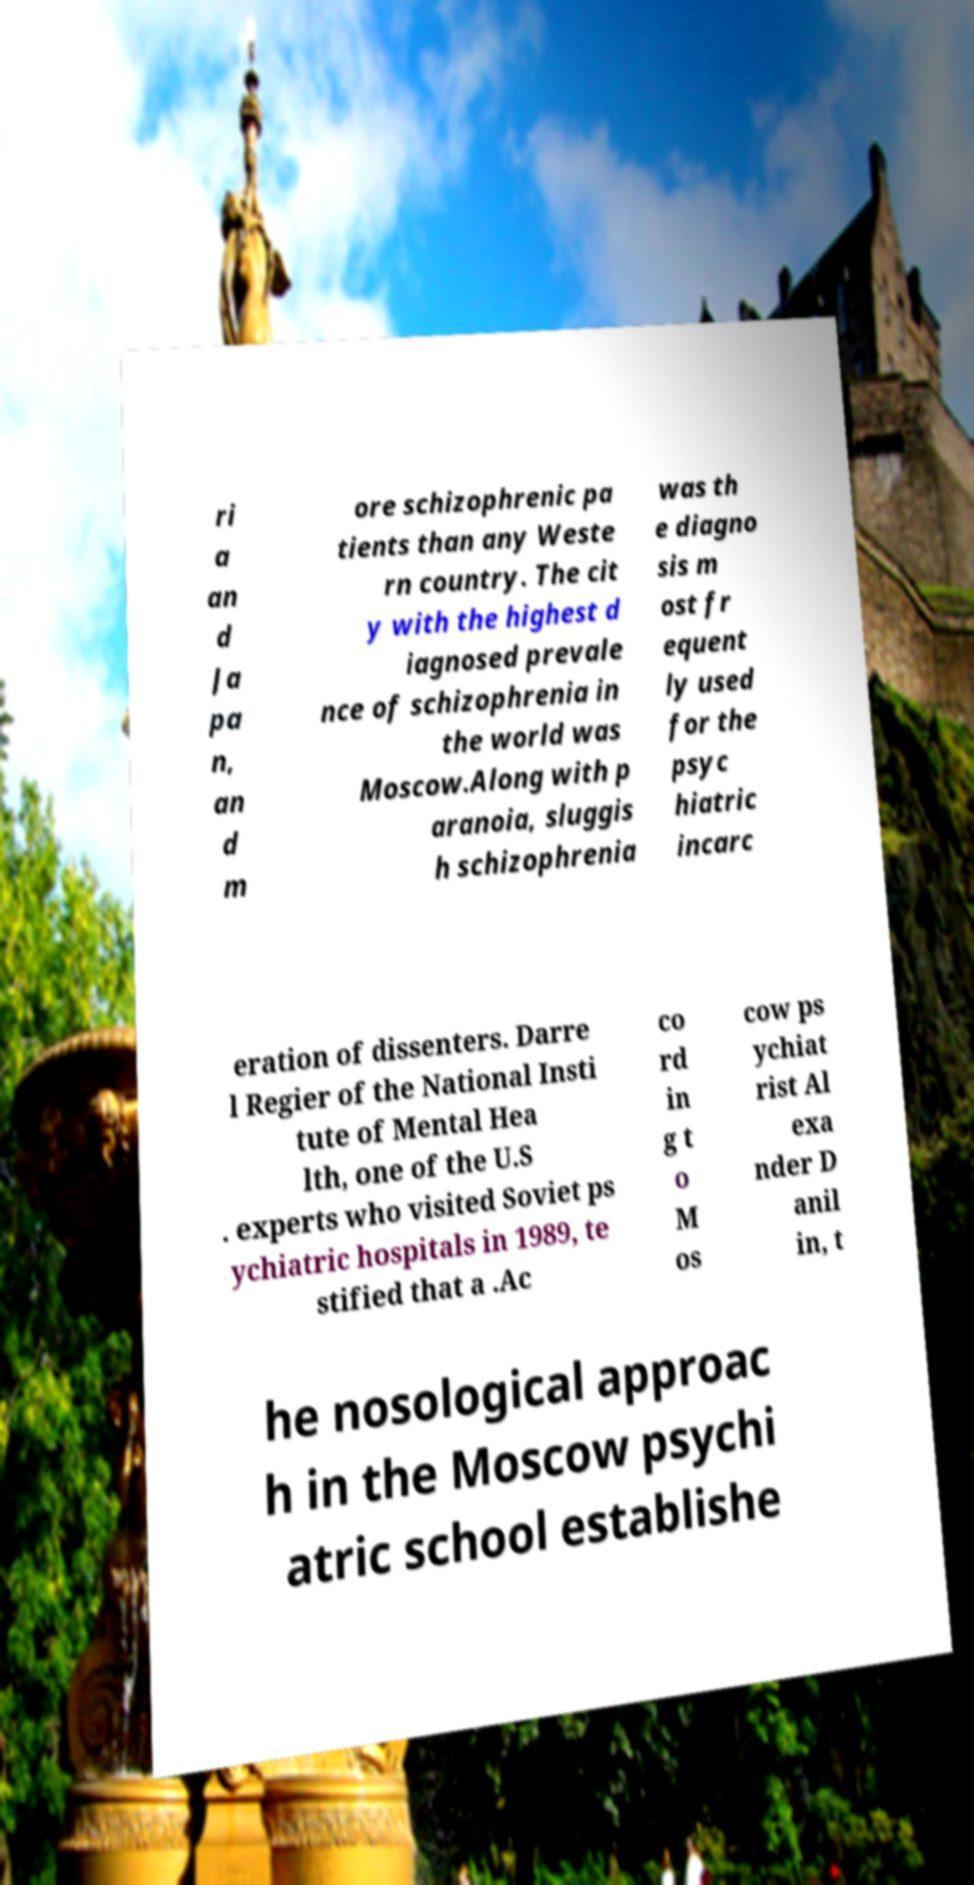I need the written content from this picture converted into text. Can you do that? ri a an d Ja pa n, an d m ore schizophrenic pa tients than any Weste rn country. The cit y with the highest d iagnosed prevale nce of schizophrenia in the world was Moscow.Along with p aranoia, sluggis h schizophrenia was th e diagno sis m ost fr equent ly used for the psyc hiatric incarc eration of dissenters. Darre l Regier of the National Insti tute of Mental Hea lth, one of the U.S . experts who visited Soviet ps ychiatric hospitals in 1989, te stified that a .Ac co rd in g t o M os cow ps ychiat rist Al exa nder D anil in, t he nosological approac h in the Moscow psychi atric school establishe 